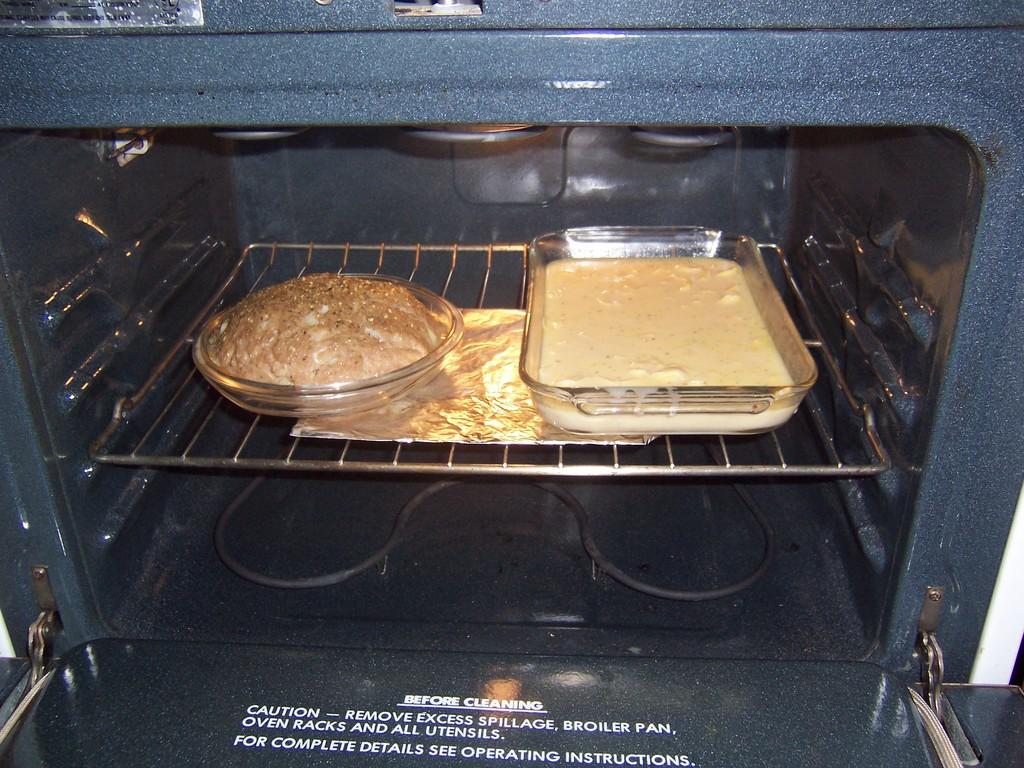What is that caution for?
Your answer should be compact. To remove excess spillage, broiler pan, oven racks, and utensils before cleaning. 